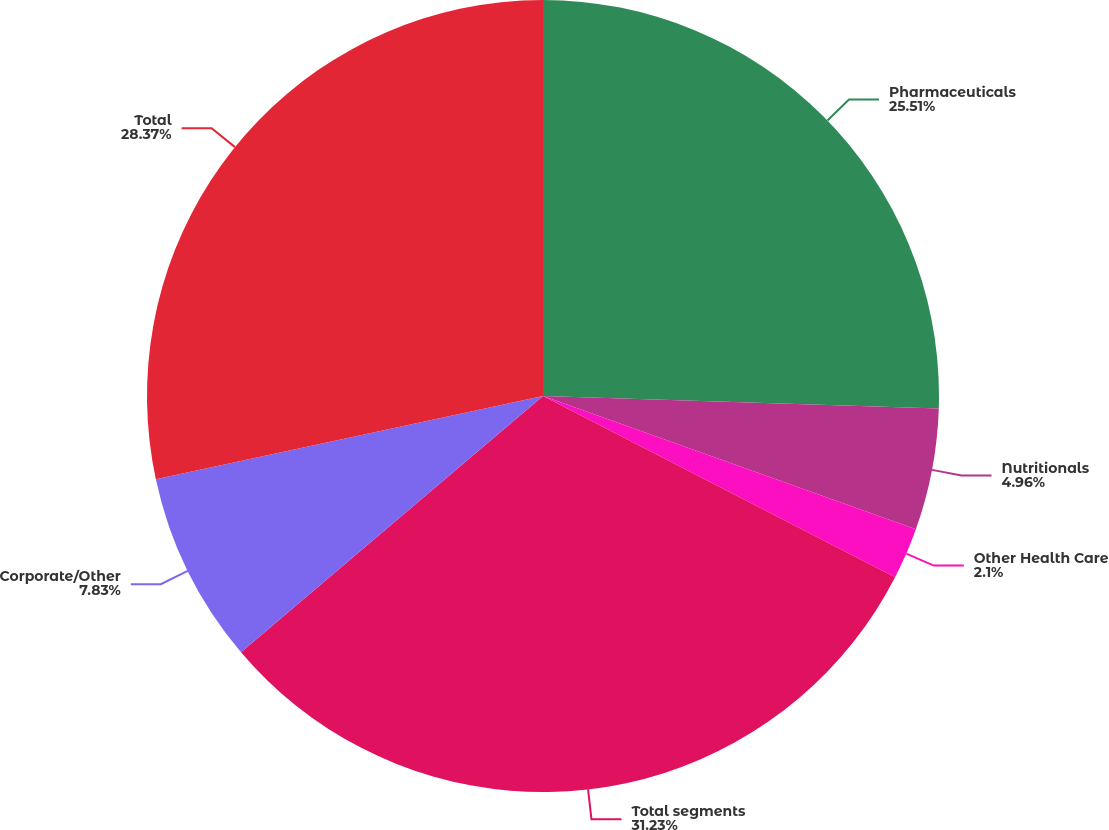Convert chart. <chart><loc_0><loc_0><loc_500><loc_500><pie_chart><fcel>Pharmaceuticals<fcel>Nutritionals<fcel>Other Health Care<fcel>Total segments<fcel>Corporate/Other<fcel>Total<nl><fcel>25.51%<fcel>4.96%<fcel>2.1%<fcel>31.24%<fcel>7.83%<fcel>28.37%<nl></chart> 